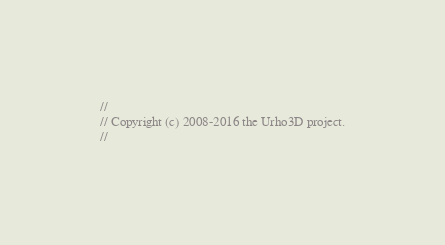Convert code to text. <code><loc_0><loc_0><loc_500><loc_500><_C++_>//
// Copyright (c) 2008-2016 the Urho3D project.
//</code> 